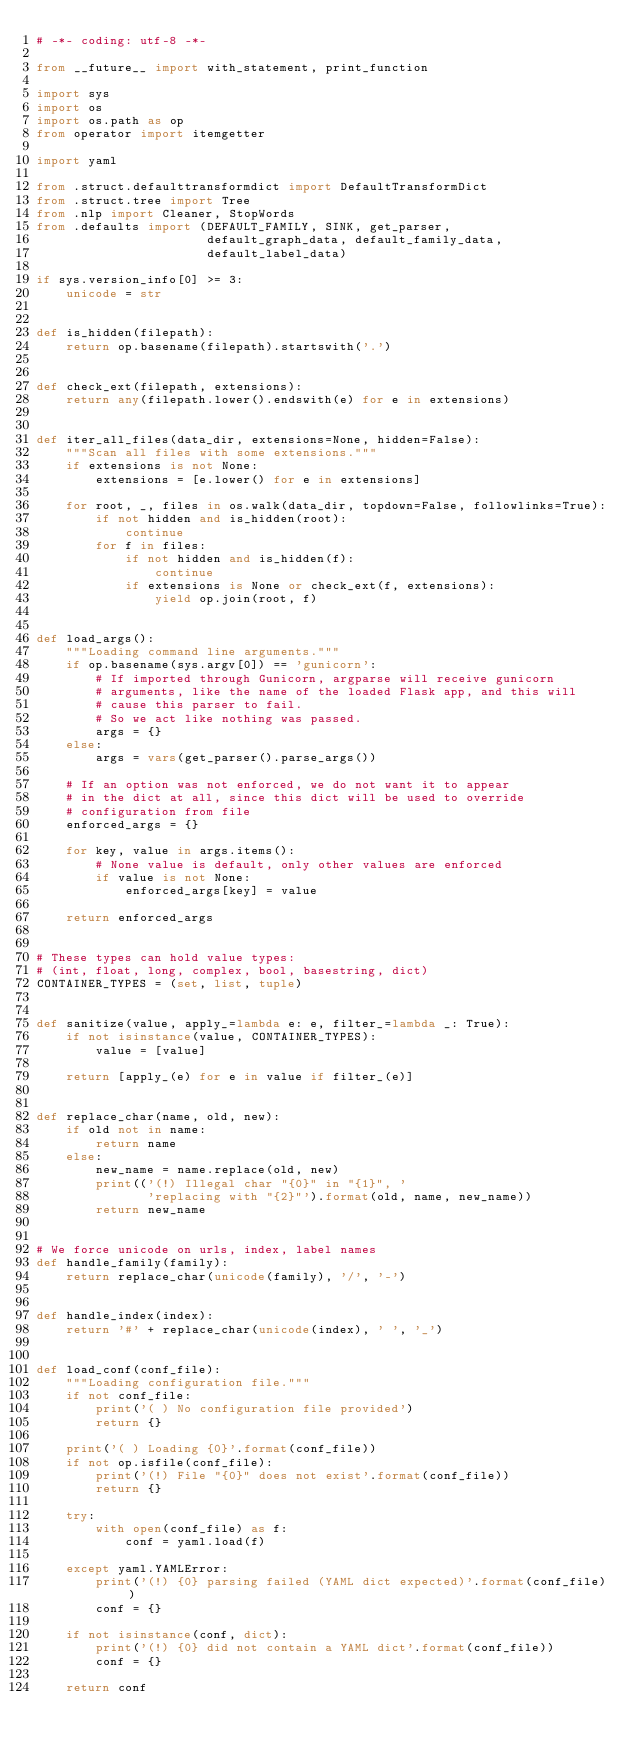<code> <loc_0><loc_0><loc_500><loc_500><_Python_># -*- coding: utf-8 -*-

from __future__ import with_statement, print_function

import sys
import os
import os.path as op
from operator import itemgetter

import yaml

from .struct.defaulttransformdict import DefaultTransformDict
from .struct.tree import Tree
from .nlp import Cleaner, StopWords
from .defaults import (DEFAULT_FAMILY, SINK, get_parser,
                       default_graph_data, default_family_data,
                       default_label_data)

if sys.version_info[0] >= 3:
    unicode = str


def is_hidden(filepath):
    return op.basename(filepath).startswith('.')


def check_ext(filepath, extensions):
    return any(filepath.lower().endswith(e) for e in extensions)


def iter_all_files(data_dir, extensions=None, hidden=False):
    """Scan all files with some extensions."""
    if extensions is not None:
        extensions = [e.lower() for e in extensions]

    for root, _, files in os.walk(data_dir, topdown=False, followlinks=True):
        if not hidden and is_hidden(root):
            continue
        for f in files:
            if not hidden and is_hidden(f):
                continue
            if extensions is None or check_ext(f, extensions):
                yield op.join(root, f)


def load_args():
    """Loading command line arguments."""
    if op.basename(sys.argv[0]) == 'gunicorn':
        # If imported through Gunicorn, argparse will receive gunicorn
        # arguments, like the name of the loaded Flask app, and this will
        # cause this parser to fail.
        # So we act like nothing was passed.
        args = {}
    else:
        args = vars(get_parser().parse_args())

    # If an option was not enforced, we do not want it to appear
    # in the dict at all, since this dict will be used to override
    # configuration from file
    enforced_args = {}

    for key, value in args.items():
        # None value is default, only other values are enforced
        if value is not None:
            enforced_args[key] = value

    return enforced_args


# These types can hold value types:
# (int, float, long, complex, bool, basestring, dict)
CONTAINER_TYPES = (set, list, tuple)


def sanitize(value, apply_=lambda e: e, filter_=lambda _: True):
    if not isinstance(value, CONTAINER_TYPES):
        value = [value]

    return [apply_(e) for e in value if filter_(e)]


def replace_char(name, old, new):
    if old not in name:
        return name
    else:
        new_name = name.replace(old, new)
        print(('(!) Illegal char "{0}" in "{1}", '
               'replacing with "{2}"').format(old, name, new_name))
        return new_name


# We force unicode on urls, index, label names
def handle_family(family):
    return replace_char(unicode(family), '/', '-')


def handle_index(index):
    return '#' + replace_char(unicode(index), ' ', '_')


def load_conf(conf_file):
    """Loading configuration file."""
    if not conf_file:
        print('( ) No configuration file provided')
        return {}

    print('( ) Loading {0}'.format(conf_file))
    if not op.isfile(conf_file):
        print('(!) File "{0}" does not exist'.format(conf_file))
        return {}

    try:
        with open(conf_file) as f:
            conf = yaml.load(f)

    except yaml.YAMLError:
        print('(!) {0} parsing failed (YAML dict expected)'.format(conf_file))
        conf = {}

    if not isinstance(conf, dict):
        print('(!) {0} did not contain a YAML dict'.format(conf_file))
        conf = {}

    return conf

</code> 